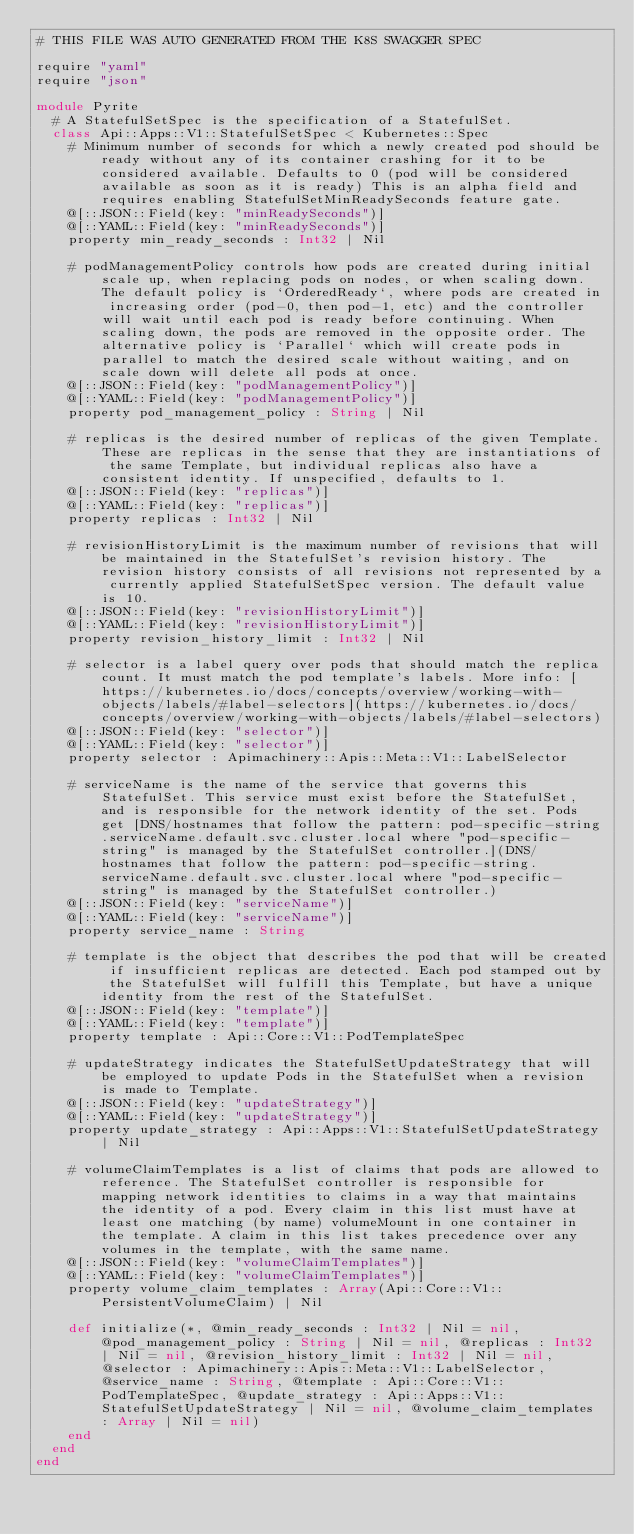<code> <loc_0><loc_0><loc_500><loc_500><_Crystal_># THIS FILE WAS AUTO GENERATED FROM THE K8S SWAGGER SPEC

require "yaml"
require "json"

module Pyrite
  # A StatefulSetSpec is the specification of a StatefulSet.
  class Api::Apps::V1::StatefulSetSpec < Kubernetes::Spec
    # Minimum number of seconds for which a newly created pod should be ready without any of its container crashing for it to be considered available. Defaults to 0 (pod will be considered available as soon as it is ready) This is an alpha field and requires enabling StatefulSetMinReadySeconds feature gate.
    @[::JSON::Field(key: "minReadySeconds")]
    @[::YAML::Field(key: "minReadySeconds")]
    property min_ready_seconds : Int32 | Nil

    # podManagementPolicy controls how pods are created during initial scale up, when replacing pods on nodes, or when scaling down. The default policy is `OrderedReady`, where pods are created in increasing order (pod-0, then pod-1, etc) and the controller will wait until each pod is ready before continuing. When scaling down, the pods are removed in the opposite order. The alternative policy is `Parallel` which will create pods in parallel to match the desired scale without waiting, and on scale down will delete all pods at once.
    @[::JSON::Field(key: "podManagementPolicy")]
    @[::YAML::Field(key: "podManagementPolicy")]
    property pod_management_policy : String | Nil

    # replicas is the desired number of replicas of the given Template. These are replicas in the sense that they are instantiations of the same Template, but individual replicas also have a consistent identity. If unspecified, defaults to 1.
    @[::JSON::Field(key: "replicas")]
    @[::YAML::Field(key: "replicas")]
    property replicas : Int32 | Nil

    # revisionHistoryLimit is the maximum number of revisions that will be maintained in the StatefulSet's revision history. The revision history consists of all revisions not represented by a currently applied StatefulSetSpec version. The default value is 10.
    @[::JSON::Field(key: "revisionHistoryLimit")]
    @[::YAML::Field(key: "revisionHistoryLimit")]
    property revision_history_limit : Int32 | Nil

    # selector is a label query over pods that should match the replica count. It must match the pod template's labels. More info: [https://kubernetes.io/docs/concepts/overview/working-with-objects/labels/#label-selectors](https://kubernetes.io/docs/concepts/overview/working-with-objects/labels/#label-selectors)
    @[::JSON::Field(key: "selector")]
    @[::YAML::Field(key: "selector")]
    property selector : Apimachinery::Apis::Meta::V1::LabelSelector

    # serviceName is the name of the service that governs this StatefulSet. This service must exist before the StatefulSet, and is responsible for the network identity of the set. Pods get [DNS/hostnames that follow the pattern: pod-specific-string.serviceName.default.svc.cluster.local where "pod-specific-string" is managed by the StatefulSet controller.](DNS/hostnames that follow the pattern: pod-specific-string.serviceName.default.svc.cluster.local where "pod-specific-string" is managed by the StatefulSet controller.)
    @[::JSON::Field(key: "serviceName")]
    @[::YAML::Field(key: "serviceName")]
    property service_name : String

    # template is the object that describes the pod that will be created if insufficient replicas are detected. Each pod stamped out by the StatefulSet will fulfill this Template, but have a unique identity from the rest of the StatefulSet.
    @[::JSON::Field(key: "template")]
    @[::YAML::Field(key: "template")]
    property template : Api::Core::V1::PodTemplateSpec

    # updateStrategy indicates the StatefulSetUpdateStrategy that will be employed to update Pods in the StatefulSet when a revision is made to Template.
    @[::JSON::Field(key: "updateStrategy")]
    @[::YAML::Field(key: "updateStrategy")]
    property update_strategy : Api::Apps::V1::StatefulSetUpdateStrategy | Nil

    # volumeClaimTemplates is a list of claims that pods are allowed to reference. The StatefulSet controller is responsible for mapping network identities to claims in a way that maintains the identity of a pod. Every claim in this list must have at least one matching (by name) volumeMount in one container in the template. A claim in this list takes precedence over any volumes in the template, with the same name.
    @[::JSON::Field(key: "volumeClaimTemplates")]
    @[::YAML::Field(key: "volumeClaimTemplates")]
    property volume_claim_templates : Array(Api::Core::V1::PersistentVolumeClaim) | Nil

    def initialize(*, @min_ready_seconds : Int32 | Nil = nil, @pod_management_policy : String | Nil = nil, @replicas : Int32 | Nil = nil, @revision_history_limit : Int32 | Nil = nil, @selector : Apimachinery::Apis::Meta::V1::LabelSelector, @service_name : String, @template : Api::Core::V1::PodTemplateSpec, @update_strategy : Api::Apps::V1::StatefulSetUpdateStrategy | Nil = nil, @volume_claim_templates : Array | Nil = nil)
    end
  end
end
</code> 